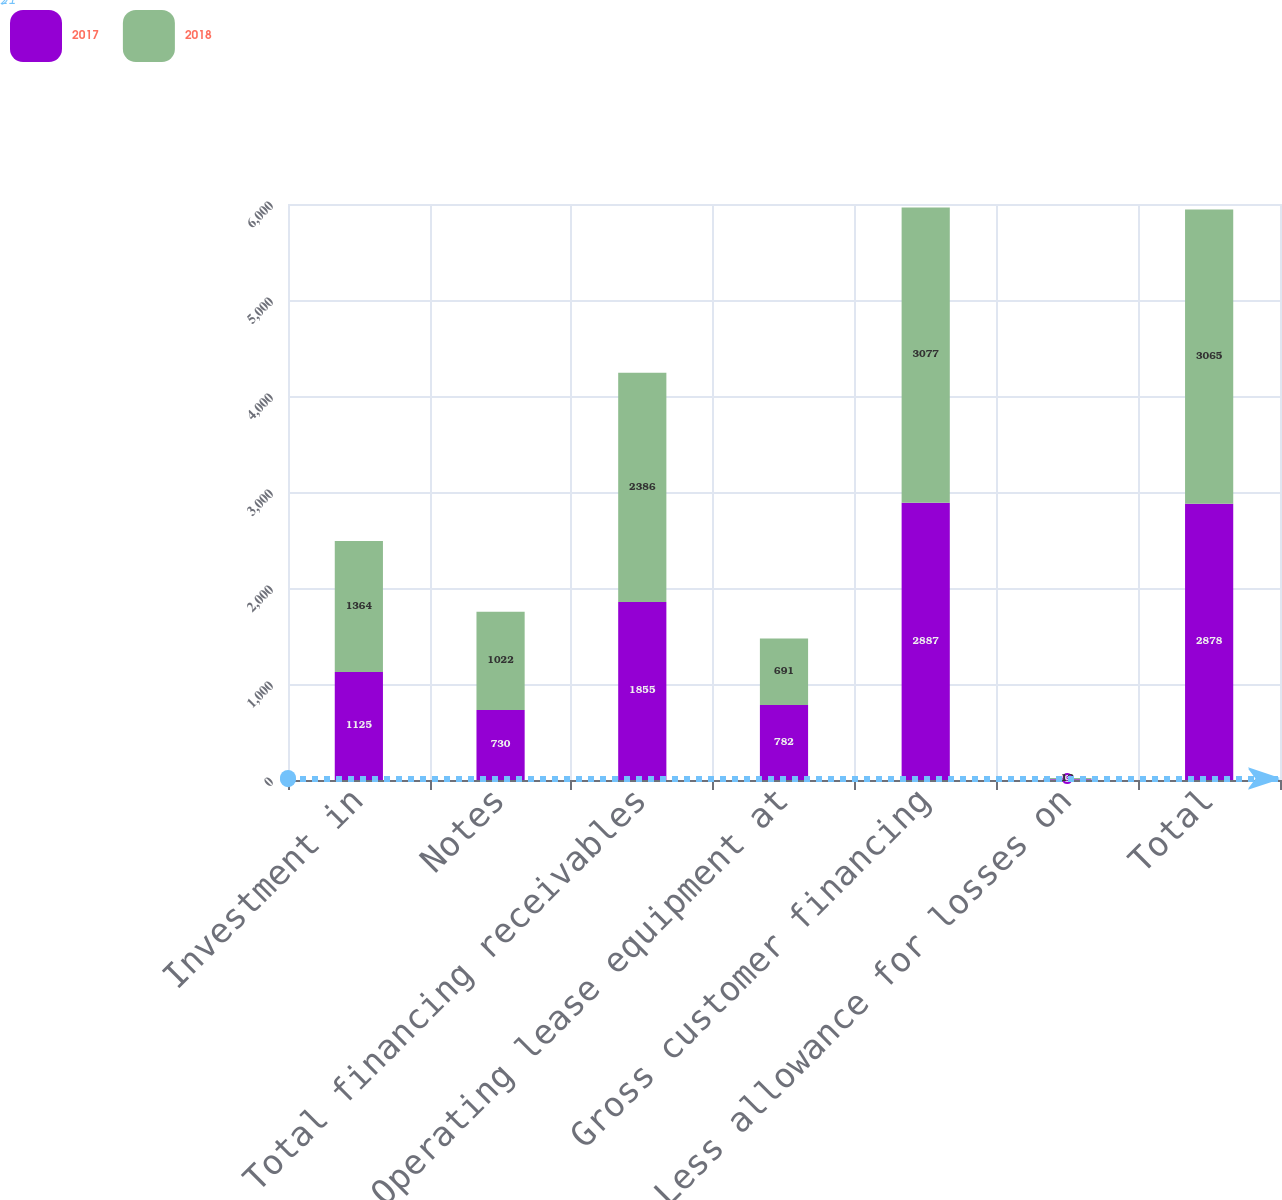Convert chart. <chart><loc_0><loc_0><loc_500><loc_500><stacked_bar_chart><ecel><fcel>Investment in<fcel>Notes<fcel>Total financing receivables<fcel>Operating lease equipment at<fcel>Gross customer financing<fcel>Less allowance for losses on<fcel>Total<nl><fcel>2017<fcel>1125<fcel>730<fcel>1855<fcel>782<fcel>2887<fcel>9<fcel>2878<nl><fcel>2018<fcel>1364<fcel>1022<fcel>2386<fcel>691<fcel>3077<fcel>12<fcel>3065<nl></chart> 